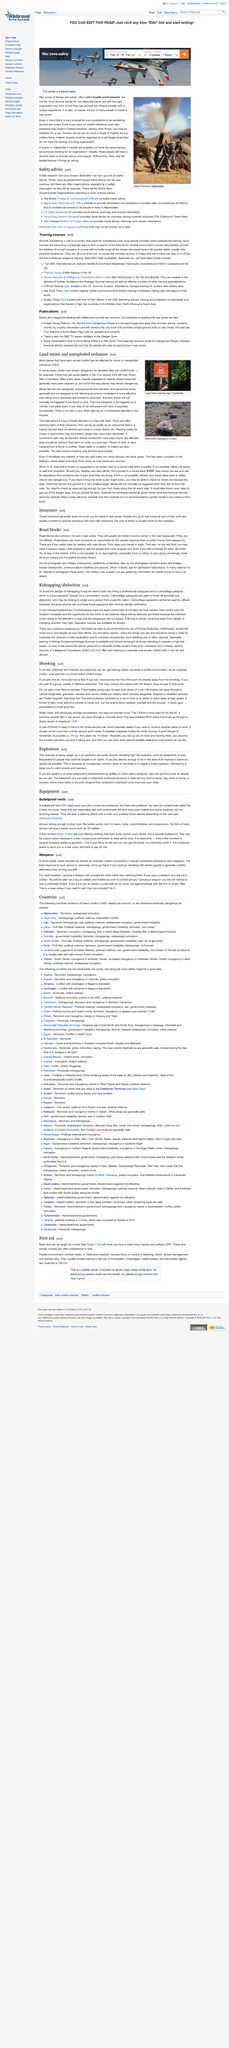Indicate a few pertinent items in this graphic. Yes, road blocks are common, not just in war zones, but also in other areas where security concerns require the implementation of such measures. It is a round that no form of body armor can stop, specifically heavy rounds such as .50 caliber. Mines fall into two categories: anti-personnel and anti-tank. Yes, it is a possibility that one may get caught in an explosion and in an area subjected to bombardment by artillery. It is indeed advisable to stay low when caught in an area subject to bombardment by artillery, as this can help to reduce the risk of injury or death. 